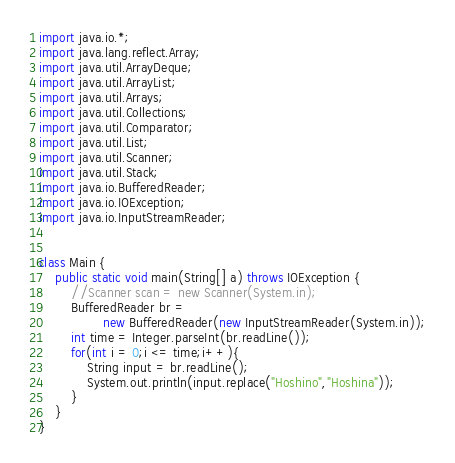Convert code to text. <code><loc_0><loc_0><loc_500><loc_500><_Java_>import java.io.*;
import java.lang.reflect.Array;
import java.util.ArrayDeque;
import java.util.ArrayList;
import java.util.Arrays;
import java.util.Collections;
import java.util.Comparator;
import java.util.List;
import java.util.Scanner;
import java.util.Stack;
import java.io.BufferedReader;
import java.io.IOException;
import java.io.InputStreamReader;
 
 
class Main {
    public static void main(String[] a) throws IOException {
        //Scanner scan = new Scanner(System.in);
        BufferedReader br =
                new BufferedReader(new InputStreamReader(System.in));
        int time = Integer.parseInt(br.readLine());
        for(int i = 0;i <= time;i++){
            String input = br.readLine();
            System.out.println(input.replace("Hoshino","Hoshina"));
        }
    }
}</code> 